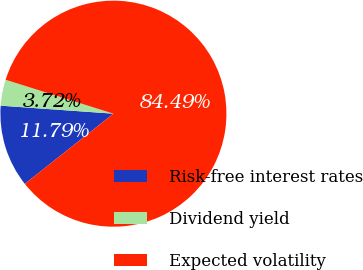Convert chart. <chart><loc_0><loc_0><loc_500><loc_500><pie_chart><fcel>Risk-free interest rates<fcel>Dividend yield<fcel>Expected volatility<nl><fcel>11.79%<fcel>3.72%<fcel>84.48%<nl></chart> 